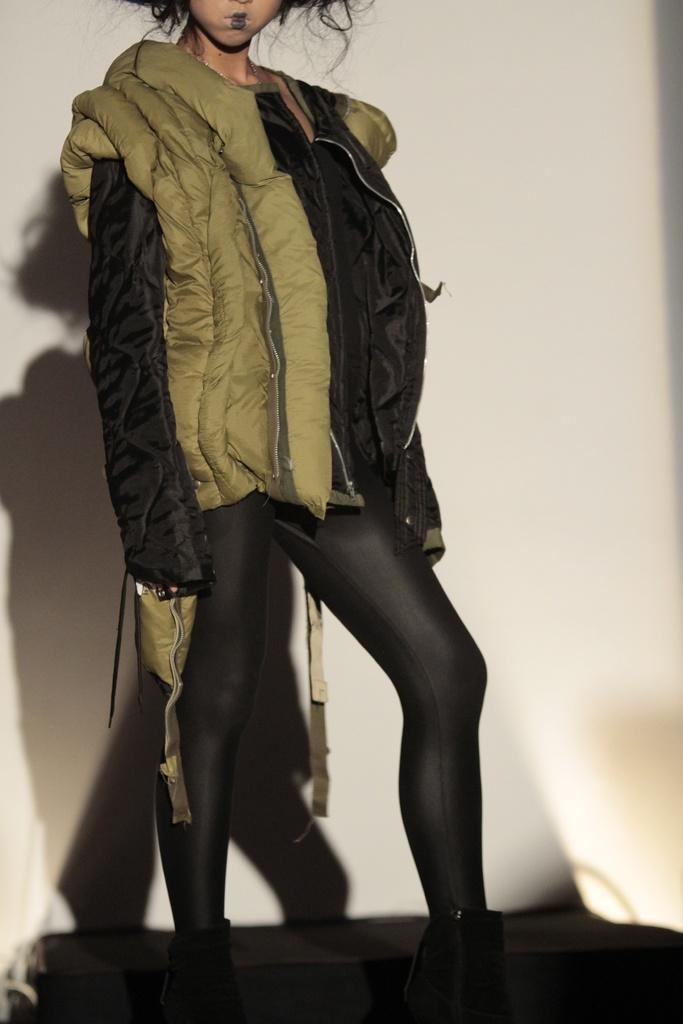What is present in the image? There is a person in the image. Can you describe the person's attire? The person is wearing a black and green dress. What is the background of the image? There is a white background in the image. Can you hear the whistle in the image? There is no whistle present in the image, so it cannot be heard. 